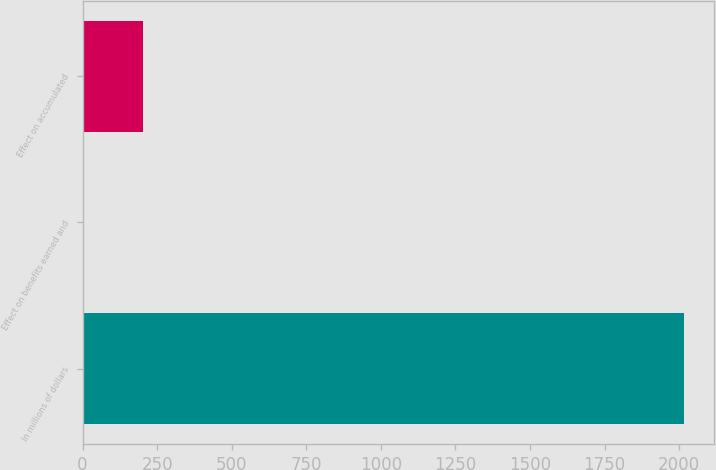<chart> <loc_0><loc_0><loc_500><loc_500><bar_chart><fcel>In millions of dollars<fcel>Effect on benefits earned and<fcel>Effect on accumulated<nl><fcel>2015<fcel>2<fcel>203.3<nl></chart> 